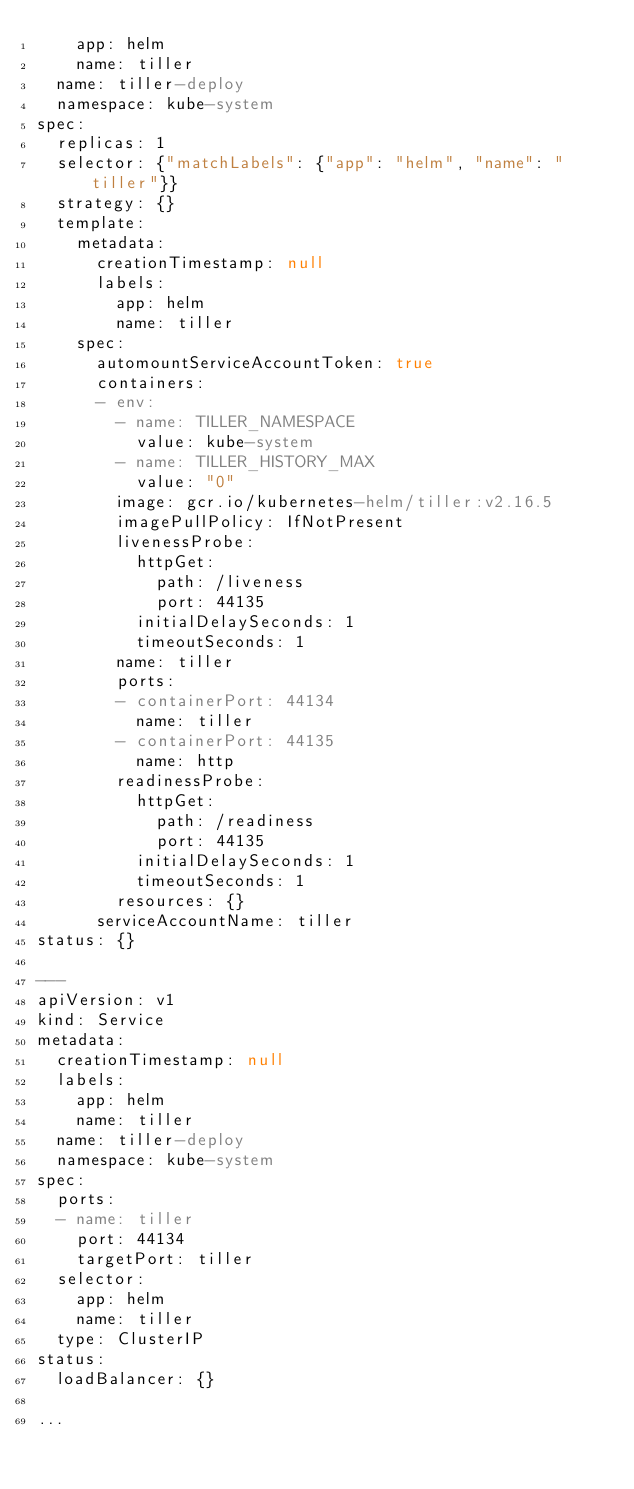Convert code to text. <code><loc_0><loc_0><loc_500><loc_500><_YAML_>    app: helm
    name: tiller
  name: tiller-deploy
  namespace: kube-system
spec:
  replicas: 1
  selector: {"matchLabels": {"app": "helm", "name": "tiller"}}
  strategy: {}
  template:
    metadata:
      creationTimestamp: null
      labels:
        app: helm
        name: tiller
    spec:
      automountServiceAccountToken: true
      containers:
      - env:
        - name: TILLER_NAMESPACE
          value: kube-system
        - name: TILLER_HISTORY_MAX
          value: "0"
        image: gcr.io/kubernetes-helm/tiller:v2.16.5
        imagePullPolicy: IfNotPresent
        livenessProbe:
          httpGet:
            path: /liveness
            port: 44135
          initialDelaySeconds: 1
          timeoutSeconds: 1
        name: tiller
        ports:
        - containerPort: 44134
          name: tiller
        - containerPort: 44135
          name: http
        readinessProbe:
          httpGet:
            path: /readiness
            port: 44135
          initialDelaySeconds: 1
          timeoutSeconds: 1
        resources: {}
      serviceAccountName: tiller
status: {}

---
apiVersion: v1
kind: Service
metadata:
  creationTimestamp: null
  labels:
    app: helm
    name: tiller
  name: tiller-deploy
  namespace: kube-system
spec:
  ports:
  - name: tiller
    port: 44134
    targetPort: tiller
  selector:
    app: helm
    name: tiller
  type: ClusterIP
status:
  loadBalancer: {}

...
</code> 